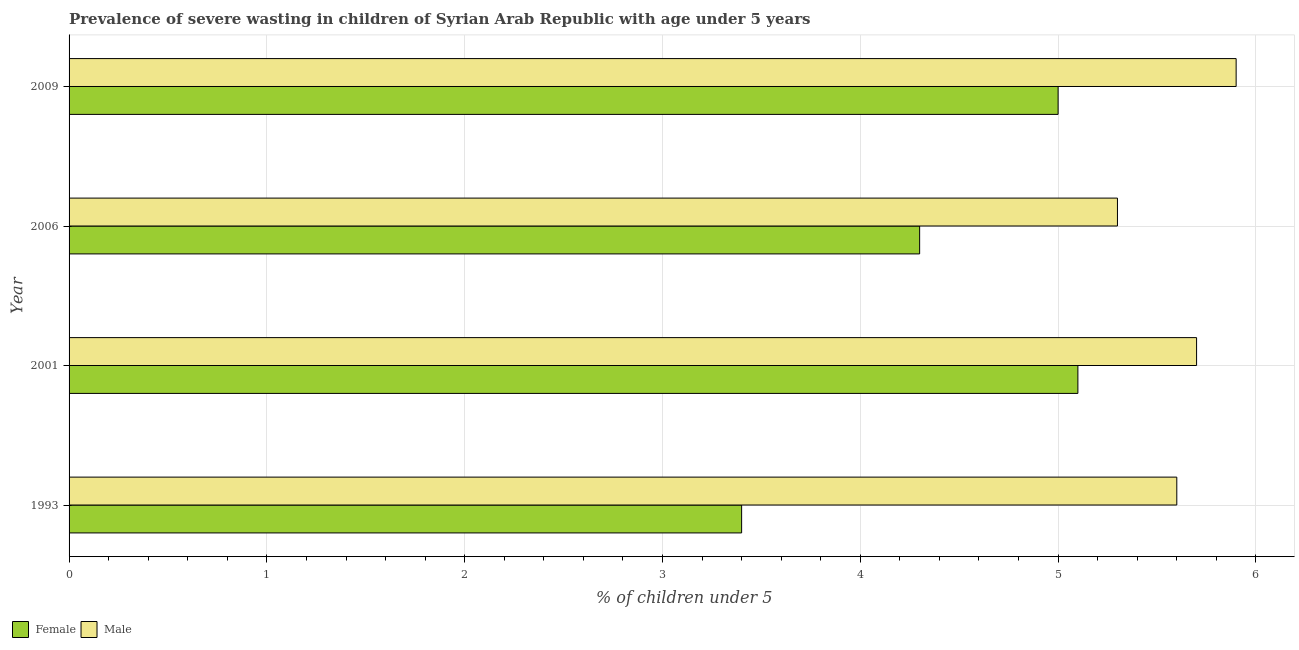How many different coloured bars are there?
Your answer should be compact. 2. How many groups of bars are there?
Your response must be concise. 4. How many bars are there on the 2nd tick from the top?
Your response must be concise. 2. What is the label of the 1st group of bars from the top?
Your answer should be compact. 2009. In how many cases, is the number of bars for a given year not equal to the number of legend labels?
Ensure brevity in your answer.  0. What is the percentage of undernourished female children in 2001?
Your response must be concise. 5.1. Across all years, what is the maximum percentage of undernourished male children?
Provide a short and direct response. 5.9. Across all years, what is the minimum percentage of undernourished male children?
Offer a very short reply. 5.3. In which year was the percentage of undernourished female children minimum?
Your answer should be compact. 1993. What is the total percentage of undernourished male children in the graph?
Offer a very short reply. 22.5. What is the difference between the percentage of undernourished male children in 2006 and the percentage of undernourished female children in 1993?
Give a very brief answer. 1.9. What is the average percentage of undernourished male children per year?
Ensure brevity in your answer.  5.62. In how many years, is the percentage of undernourished male children greater than 1.6 %?
Make the answer very short. 4. What is the ratio of the percentage of undernourished female children in 1993 to that in 2009?
Keep it short and to the point. 0.68. What is the difference between the highest and the second highest percentage of undernourished male children?
Make the answer very short. 0.2. In how many years, is the percentage of undernourished female children greater than the average percentage of undernourished female children taken over all years?
Your response must be concise. 2. Is the sum of the percentage of undernourished male children in 2006 and 2009 greater than the maximum percentage of undernourished female children across all years?
Your response must be concise. Yes. What does the 2nd bar from the top in 2009 represents?
Make the answer very short. Female. What does the 2nd bar from the bottom in 2001 represents?
Your answer should be very brief. Male. Are all the bars in the graph horizontal?
Give a very brief answer. Yes. How many years are there in the graph?
Provide a short and direct response. 4. What is the difference between two consecutive major ticks on the X-axis?
Offer a terse response. 1. Are the values on the major ticks of X-axis written in scientific E-notation?
Keep it short and to the point. No. Does the graph contain any zero values?
Ensure brevity in your answer.  No. Does the graph contain grids?
Ensure brevity in your answer.  Yes. Where does the legend appear in the graph?
Provide a short and direct response. Bottom left. How many legend labels are there?
Keep it short and to the point. 2. What is the title of the graph?
Your answer should be compact. Prevalence of severe wasting in children of Syrian Arab Republic with age under 5 years. Does "Underweight" appear as one of the legend labels in the graph?
Keep it short and to the point. No. What is the label or title of the X-axis?
Provide a short and direct response.  % of children under 5. What is the  % of children under 5 of Female in 1993?
Offer a very short reply. 3.4. What is the  % of children under 5 in Male in 1993?
Provide a succinct answer. 5.6. What is the  % of children under 5 in Female in 2001?
Make the answer very short. 5.1. What is the  % of children under 5 of Male in 2001?
Your response must be concise. 5.7. What is the  % of children under 5 in Female in 2006?
Your answer should be very brief. 4.3. What is the  % of children under 5 of Male in 2006?
Ensure brevity in your answer.  5.3. What is the  % of children under 5 of Male in 2009?
Your answer should be very brief. 5.9. Across all years, what is the maximum  % of children under 5 in Female?
Ensure brevity in your answer.  5.1. Across all years, what is the maximum  % of children under 5 in Male?
Offer a terse response. 5.9. Across all years, what is the minimum  % of children under 5 of Female?
Offer a very short reply. 3.4. Across all years, what is the minimum  % of children under 5 of Male?
Keep it short and to the point. 5.3. What is the difference between the  % of children under 5 of Female in 1993 and that in 2001?
Make the answer very short. -1.7. What is the difference between the  % of children under 5 of Female in 1993 and that in 2006?
Provide a succinct answer. -0.9. What is the difference between the  % of children under 5 of Male in 1993 and that in 2006?
Ensure brevity in your answer.  0.3. What is the difference between the  % of children under 5 in Male in 2001 and that in 2006?
Your response must be concise. 0.4. What is the difference between the  % of children under 5 in Male in 2001 and that in 2009?
Your response must be concise. -0.2. What is the difference between the  % of children under 5 of Female in 1993 and the  % of children under 5 of Male in 2001?
Offer a terse response. -2.3. What is the difference between the  % of children under 5 in Female in 1993 and the  % of children under 5 in Male in 2009?
Offer a very short reply. -2.5. What is the difference between the  % of children under 5 of Female in 2001 and the  % of children under 5 of Male in 2006?
Your answer should be very brief. -0.2. What is the difference between the  % of children under 5 of Female in 2001 and the  % of children under 5 of Male in 2009?
Offer a very short reply. -0.8. What is the difference between the  % of children under 5 in Female in 2006 and the  % of children under 5 in Male in 2009?
Keep it short and to the point. -1.6. What is the average  % of children under 5 of Female per year?
Offer a terse response. 4.45. What is the average  % of children under 5 in Male per year?
Offer a very short reply. 5.62. In the year 1993, what is the difference between the  % of children under 5 in Female and  % of children under 5 in Male?
Offer a very short reply. -2.2. In the year 2009, what is the difference between the  % of children under 5 in Female and  % of children under 5 in Male?
Your answer should be very brief. -0.9. What is the ratio of the  % of children under 5 of Female in 1993 to that in 2001?
Make the answer very short. 0.67. What is the ratio of the  % of children under 5 in Male in 1993 to that in 2001?
Provide a short and direct response. 0.98. What is the ratio of the  % of children under 5 of Female in 1993 to that in 2006?
Make the answer very short. 0.79. What is the ratio of the  % of children under 5 in Male in 1993 to that in 2006?
Offer a very short reply. 1.06. What is the ratio of the  % of children under 5 in Female in 1993 to that in 2009?
Provide a succinct answer. 0.68. What is the ratio of the  % of children under 5 of Male in 1993 to that in 2009?
Keep it short and to the point. 0.95. What is the ratio of the  % of children under 5 in Female in 2001 to that in 2006?
Your answer should be very brief. 1.19. What is the ratio of the  % of children under 5 of Male in 2001 to that in 2006?
Your answer should be very brief. 1.08. What is the ratio of the  % of children under 5 in Female in 2001 to that in 2009?
Keep it short and to the point. 1.02. What is the ratio of the  % of children under 5 of Male in 2001 to that in 2009?
Offer a terse response. 0.97. What is the ratio of the  % of children under 5 in Female in 2006 to that in 2009?
Provide a succinct answer. 0.86. What is the ratio of the  % of children under 5 of Male in 2006 to that in 2009?
Offer a very short reply. 0.9. What is the difference between the highest and the second highest  % of children under 5 in Female?
Offer a terse response. 0.1. 